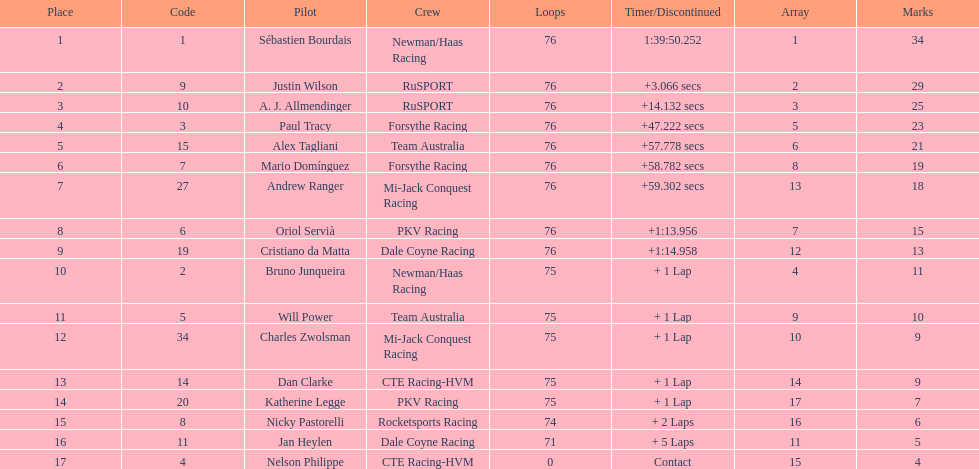What driver earned the most points? Sebastien Bourdais. 